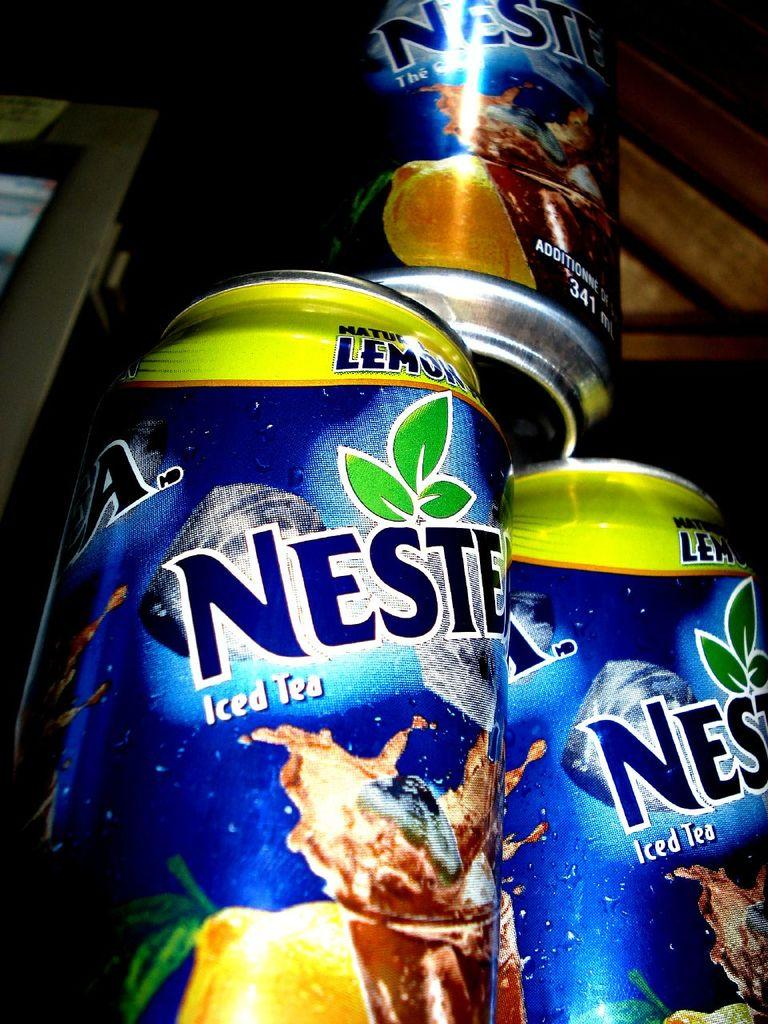<image>
Present a compact description of the photo's key features. the word Nest that is on a can 